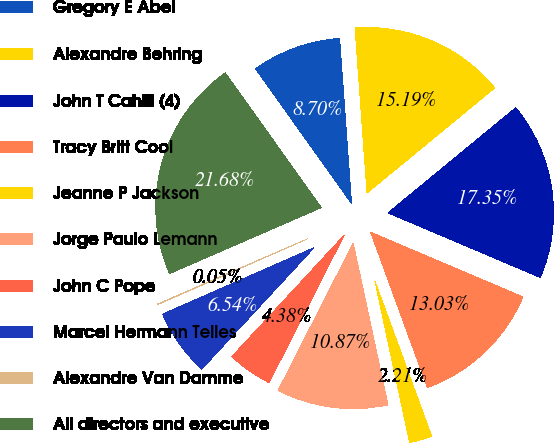Convert chart to OTSL. <chart><loc_0><loc_0><loc_500><loc_500><pie_chart><fcel>Gregory E Abel<fcel>Alexandre Behring<fcel>John T Cahill (4)<fcel>Tracy Britt Cool<fcel>Jeanne P Jackson<fcel>Jorge Paulo Lemann<fcel>John C Pope<fcel>Marcel Hermann Telles<fcel>Alexandre Van Damme<fcel>All directors and executive<nl><fcel>8.7%<fcel>15.19%<fcel>17.35%<fcel>13.03%<fcel>2.21%<fcel>10.87%<fcel>4.38%<fcel>6.54%<fcel>0.05%<fcel>21.68%<nl></chart> 